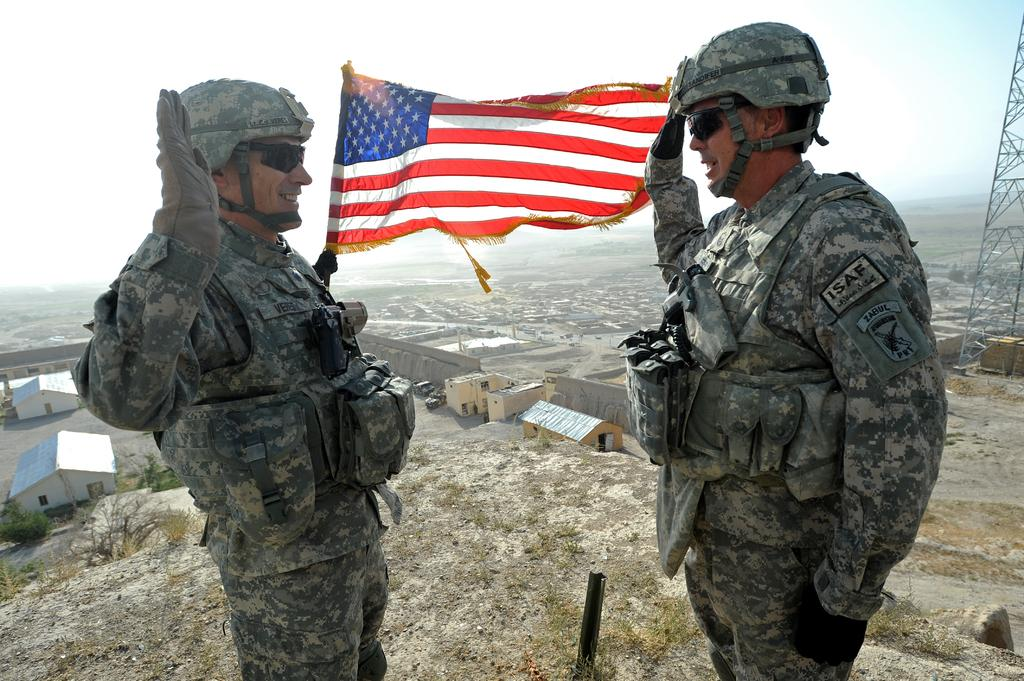How many people are in the image? There are two men in the image. What is the flag associated with in the image? The flag is present in the image, but its specific association is not clear. What type of structures can be seen in the image? There are sheds and a power tower in the image. What type of natural elements are present in the image? There are trees in the image. What else can be seen in the image besides the mentioned elements? There are other objects in the image. What is visible in the background of the image? The sky is visible in the background of the image. What type of lace is being used to decorate the jail in the image? There is no jail or lace present in the image. 